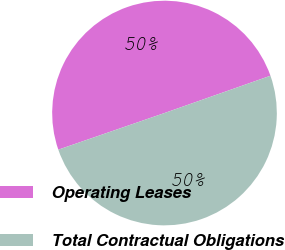Convert chart. <chart><loc_0><loc_0><loc_500><loc_500><pie_chart><fcel>Operating Leases<fcel>Total Contractual Obligations<nl><fcel>49.9%<fcel>50.1%<nl></chart> 